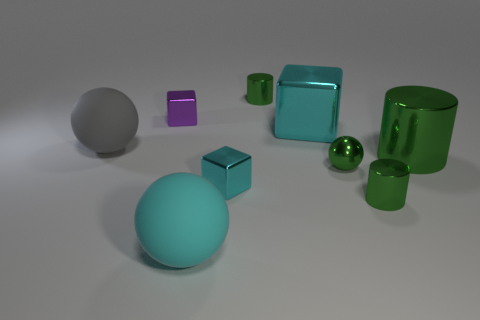Are there any tiny green shiny cylinders that are on the left side of the cube in front of the large matte ball behind the big green shiny object? no 